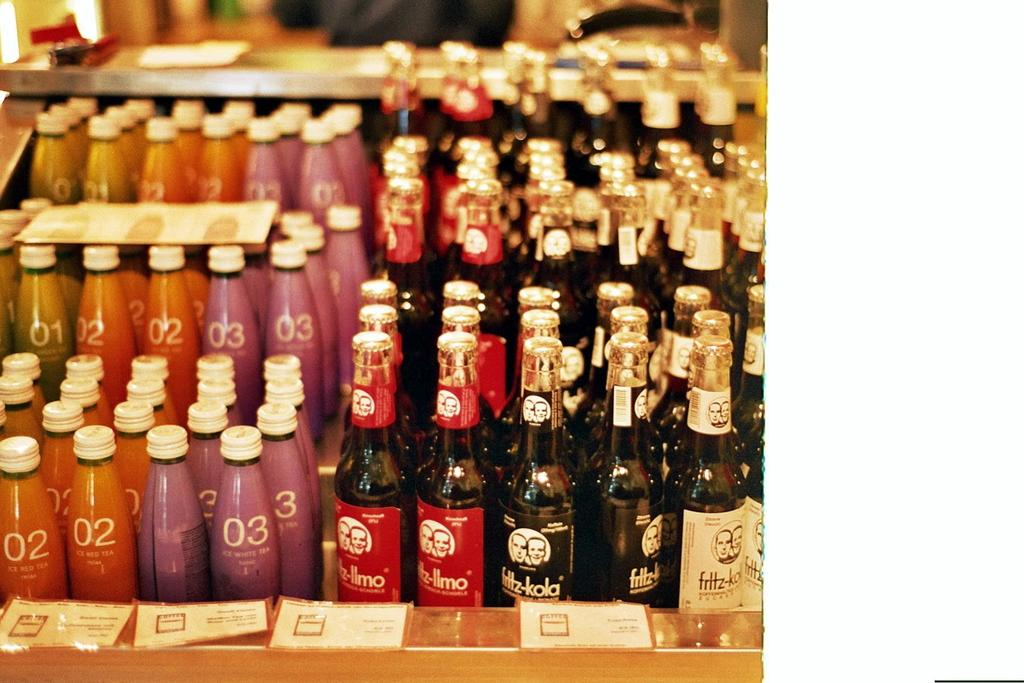<image>
Describe the image concisely. Bottles of ice red  and ice white tea are lined up next to one another. 